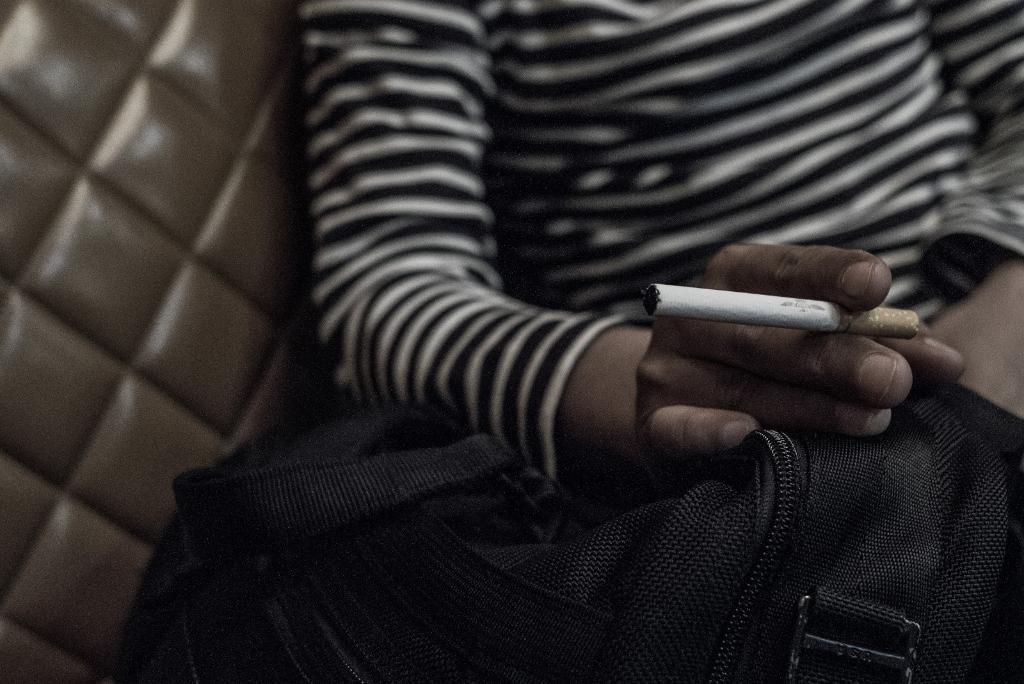Please provide a concise description of this image. In this image we can see a person wearing black and white color T-shirt is holding a cigarette. Here we can see the black color bag. This part of the image is blurred. 